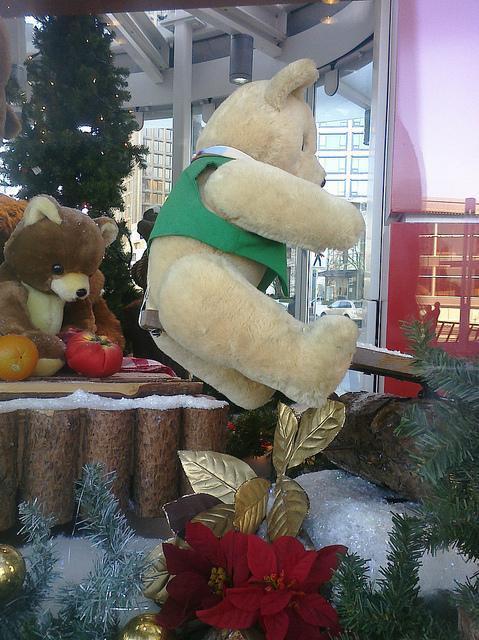How many teddy bears are in the picture?
Give a very brief answer. 2. How many people are sitting in the 4th row in the image?
Give a very brief answer. 0. 